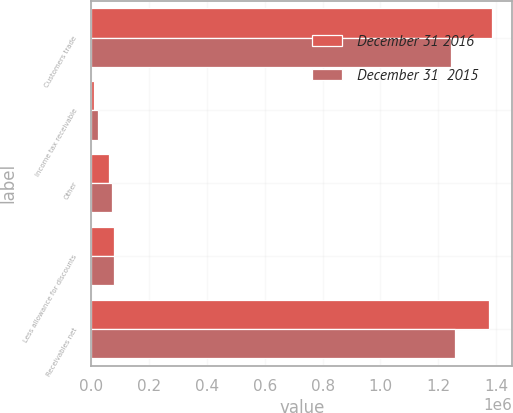Convert chart. <chart><loc_0><loc_0><loc_500><loc_500><stacked_bar_chart><ecel><fcel>Customers trade<fcel>Income tax receivable<fcel>Other<fcel>Less allowance for discounts<fcel>Receivables net<nl><fcel>December 31 2016<fcel>1.38631e+06<fcel>8616<fcel>59564<fcel>78335<fcel>1.37615e+06<nl><fcel>December 31  2015<fcel>1.24353e+06<fcel>21835<fcel>71084<fcel>78947<fcel>1.2575e+06<nl></chart> 